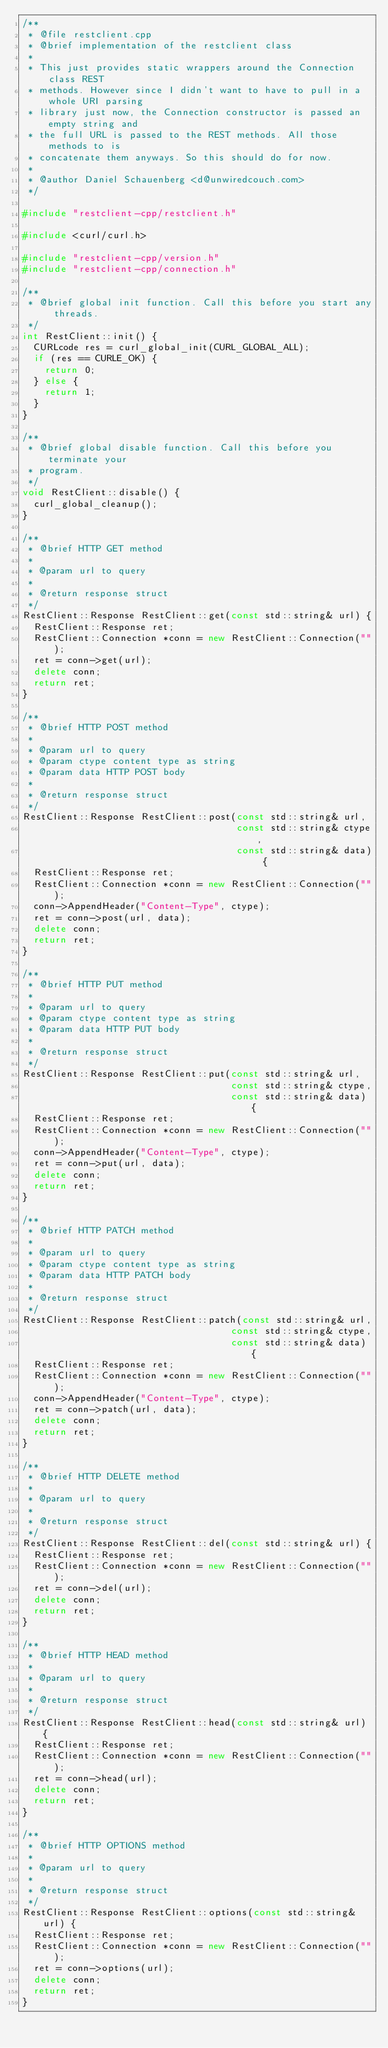<code> <loc_0><loc_0><loc_500><loc_500><_C++_>/**
 * @file restclient.cpp
 * @brief implementation of the restclient class
 *
 * This just provides static wrappers around the Connection class REST
 * methods. However since I didn't want to have to pull in a whole URI parsing
 * library just now, the Connection constructor is passed an empty string and
 * the full URL is passed to the REST methods. All those methods to is
 * concatenate them anyways. So this should do for now.
 *
 * @author Daniel Schauenberg <d@unwiredcouch.com>
 */

#include "restclient-cpp/restclient.h"

#include <curl/curl.h>

#include "restclient-cpp/version.h"
#include "restclient-cpp/connection.h"

/**
 * @brief global init function. Call this before you start any threads.
 */
int RestClient::init() {
  CURLcode res = curl_global_init(CURL_GLOBAL_ALL);
  if (res == CURLE_OK) {
    return 0;
  } else {
    return 1;
  }
}

/**
 * @brief global disable function. Call this before you terminate your
 * program.
 */
void RestClient::disable() {
  curl_global_cleanup();
}

/**
 * @brief HTTP GET method
 *
 * @param url to query
 *
 * @return response struct
 */
RestClient::Response RestClient::get(const std::string& url) {
  RestClient::Response ret;
  RestClient::Connection *conn = new RestClient::Connection("");
  ret = conn->get(url);
  delete conn;
  return ret;
}

/**
 * @brief HTTP POST method
 *
 * @param url to query
 * @param ctype content type as string
 * @param data HTTP POST body
 *
 * @return response struct
 */
RestClient::Response RestClient::post(const std::string& url,
                                      const std::string& ctype,
                                      const std::string& data) {
  RestClient::Response ret;
  RestClient::Connection *conn = new RestClient::Connection("");
  conn->AppendHeader("Content-Type", ctype);
  ret = conn->post(url, data);
  delete conn;
  return ret;
}

/**
 * @brief HTTP PUT method
 *
 * @param url to query
 * @param ctype content type as string
 * @param data HTTP PUT body
 *
 * @return response struct
 */
RestClient::Response RestClient::put(const std::string& url,
                                     const std::string& ctype,
                                     const std::string& data) {
  RestClient::Response ret;
  RestClient::Connection *conn = new RestClient::Connection("");
  conn->AppendHeader("Content-Type", ctype);
  ret = conn->put(url, data);
  delete conn;
  return ret;
}

/**
 * @brief HTTP PATCH method
 *
 * @param url to query
 * @param ctype content type as string
 * @param data HTTP PATCH body
 *
 * @return response struct
 */
RestClient::Response RestClient::patch(const std::string& url,
                                     const std::string& ctype,
                                     const std::string& data) {
  RestClient::Response ret;
  RestClient::Connection *conn = new RestClient::Connection("");
  conn->AppendHeader("Content-Type", ctype);
  ret = conn->patch(url, data);
  delete conn;
  return ret;
}

/**
 * @brief HTTP DELETE method
 *
 * @param url to query
 *
 * @return response struct
 */
RestClient::Response RestClient::del(const std::string& url) {
  RestClient::Response ret;
  RestClient::Connection *conn = new RestClient::Connection("");
  ret = conn->del(url);
  delete conn;
  return ret;
}

/**
 * @brief HTTP HEAD method
 *
 * @param url to query
 *
 * @return response struct
 */
RestClient::Response RestClient::head(const std::string& url) {
  RestClient::Response ret;
  RestClient::Connection *conn = new RestClient::Connection("");
  ret = conn->head(url);
  delete conn;
  return ret;
}

/**
 * @brief HTTP OPTIONS method
 *
 * @param url to query
 *
 * @return response struct
 */
RestClient::Response RestClient::options(const std::string& url) {
  RestClient::Response ret;
  RestClient::Connection *conn = new RestClient::Connection("");
  ret = conn->options(url);
  delete conn;
  return ret;
}
</code> 